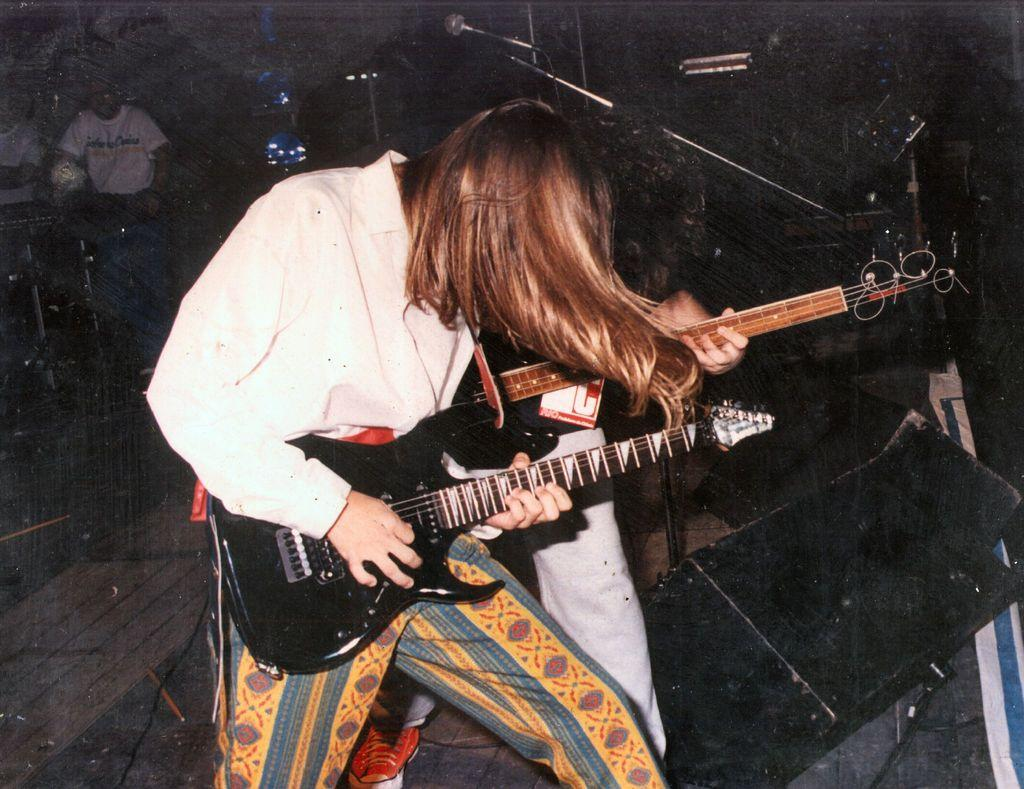What is the main subject of the image? The main subject of the image is a man holding a guitar. Can you describe the other person in the image? There is another man behind the first man, also holding a guitar. Are there any other people visible in the image? Yes, in the background, there are two more persons. What object can be seen in the background that might be related to the activity of the people in the image? There is a microphone visible in the background. What is the son of the man holding the guitar doing during the rainstorm in downtown? There is no son, rainstorm, or downtown mentioned in the image. The image only shows two men holding guitars, two other persons in the background, and a microphone. 